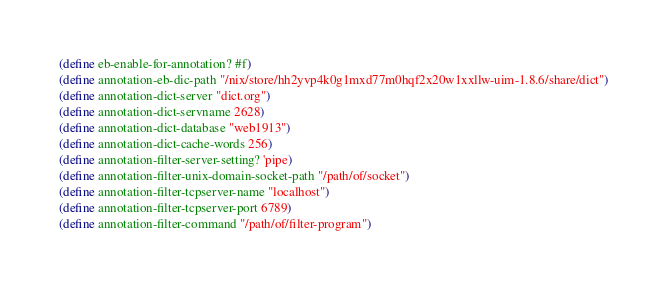<code> <loc_0><loc_0><loc_500><loc_500><_Scheme_>(define eb-enable-for-annotation? #f)
(define annotation-eb-dic-path "/nix/store/hh2yvp4k0g1mxd77m0hqf2x20w1xxllw-uim-1.8.6/share/dict")
(define annotation-dict-server "dict.org")
(define annotation-dict-servname 2628)
(define annotation-dict-database "web1913")
(define annotation-dict-cache-words 256)
(define annotation-filter-server-setting? 'pipe)
(define annotation-filter-unix-domain-socket-path "/path/of/socket")
(define annotation-filter-tcpserver-name "localhost")
(define annotation-filter-tcpserver-port 6789)
(define annotation-filter-command "/path/of/filter-program")
</code> 